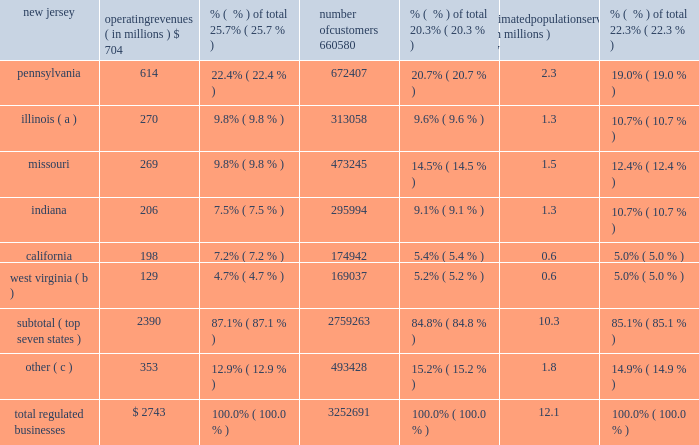Part i item 1 .
Business our company founded in 1886 , american water works company , inc .
( the 201ccompany 201d or 201camerican water 201d ) is a holding company incorporated in delaware .
American water is the largest and most geographically diverse investor owned publicly-traded united states water and wastewater utility company , as measured by both operating revenues and population served .
We employ approximately 6700 professionals who provide drinking water , wastewater and other related services to an estimated 15 million people in 47 states , the district of columbia and ontario , canada .
Operating segments we conduct our business primarily through our regulated businesses segment .
We also operate several market-based businesses that provide a broad range of related and complementary water and wastewater services , which include four operating segments that individually do not meet the criteria of a reportable segment in accordance with generally accepted accounting principles in the united states ( 201cgaap 201d ) .
These four non- reportable operating segments are collectively presented as our 201cmarket-based businesses , 201d which is consistent with how management assesses the results of these businesses .
Additional information can be found in item 7 2014management 2019s discussion and analysis of financial condition and results of operations and note 19 2014segment information in the notes to consolidated financial statements .
Regulated businesses our primary business involves the ownership of subsidiaries that provide water and wastewater utility services to residential , commercial , industrial and other customers , including sale for resale and public authority customers .
Our subsidiaries that provide these services operate in approximately 1600 communities in 16 states in the united states and are generally subject to regulation by certain state commissions or other entities engaged in utility regulation , referred to as public utility commissions or ( 201cpucs 201d ) .
The federal and state governments also regulate environmental , health and safety , and water quality matters .
We report the results of the services provided by our utilities in our regulated businesses segment .
Our regulated businesses segment 2019s operating revenues were $ 2743 million for 2015 , $ 2674 million for 2014 and $ 2594 million for 2013 , accounting for 86.8% ( 86.8 % ) , 88.8% ( 88.8 % ) and 90.1% ( 90.1 % ) , respectively , of total operating revenues for the same periods .
The table summarizes our regulated businesses 2019 operating revenues , number of customers and estimated population served by state , each as of december 31 , 2015 : operating revenues ( in millions ) % (  % ) of total number of customers % (  % ) of total estimated population served ( in millions ) % (  % ) of total .
( a ) includes illinois-american water company and american lake water company .
( b ) includes west virginia-american water company and its subsidiary bluefield valley water works company .
( c ) includes data from our utilities in the following states : georgia , hawaii , iowa , kentucky , maryland , michigan , new york , tennessee and virginia. .
What is the current customer penetration in the missouri market area? 
Computations: (473245 / (1.5 * 1000000))
Answer: 0.3155. 